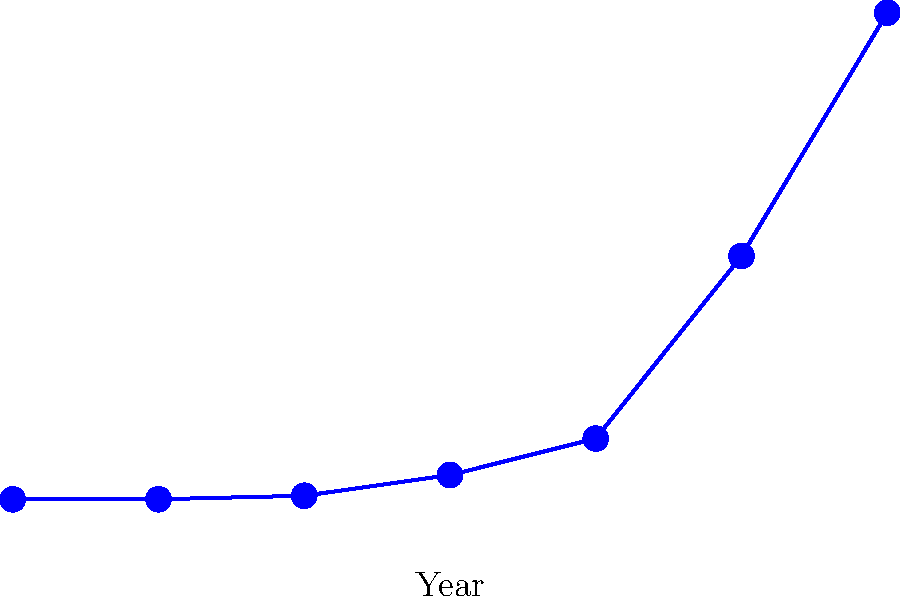As a communications expert, you need to explain the trend in exoplanet discoveries to the public. Based on the line graph, what would be the most accurate way to describe the rate of exoplanet discoveries between 2000 and 2020? To accurately describe the rate of exoplanet discoveries between 2000 and 2020, we need to analyze the graph's shape and steepness during this period. Let's break it down step-by-step:

1. Observe the overall trend: The line shows an upward trend, indicating an increase in exoplanet discoveries over time.

2. Analyze the curve: The line is not straight but curves upward, suggesting the rate of discovery is increasing over time.

3. Compare the slope at different points:
   - From 2000 to 2010: The line has a gentle upward slope.
   - From 2010 to 2020: The line becomes much steeper, indicating a faster rate of discovery.

4. Quantify the change:
   - In 2000, about 30 exoplanets were known.
   - By 2010, this increased to about 500 exoplanets.
   - By 2020, the number reached approximately 4000 exoplanets.

5. Calculate the rate of change:
   - 2000-2010: Approximately 470 exoplanets discovered in 10 years.
   - 2010-2020: Approximately 3500 exoplanets discovered in 10 years.

Given this analysis, the most accurate way to describe the rate of exoplanet discoveries between 2000 and 2020 would be to say it was "exponentially increasing" or "accelerating rapidly." This phrase captures both the overall increase and the fact that the rate of discovery itself was increasing over time.
Answer: Exponentially increasing 